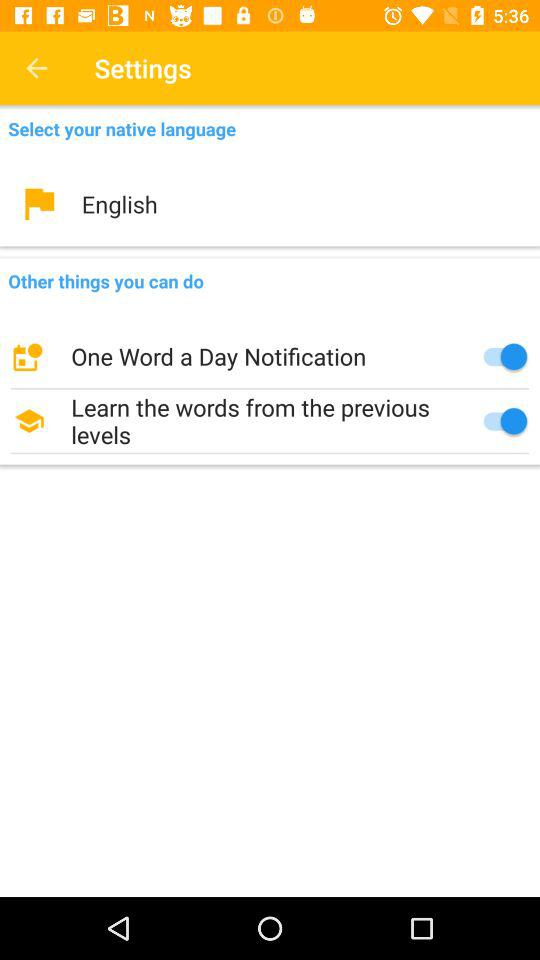How many items have a switch under them?
Answer the question using a single word or phrase. 2 